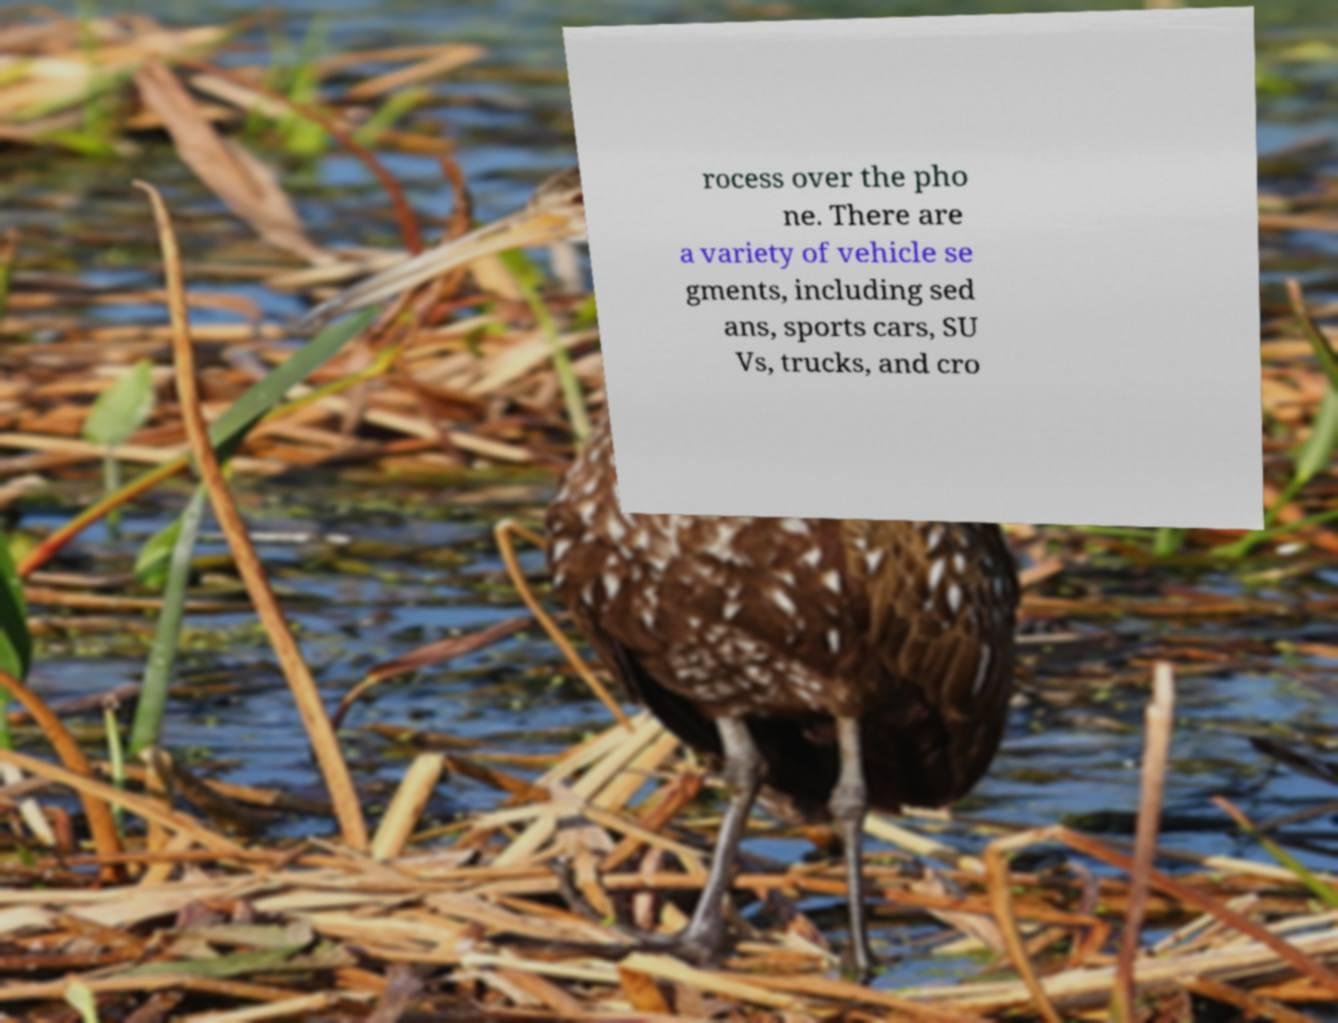Can you accurately transcribe the text from the provided image for me? rocess over the pho ne. There are a variety of vehicle se gments, including sed ans, sports cars, SU Vs, trucks, and cro 